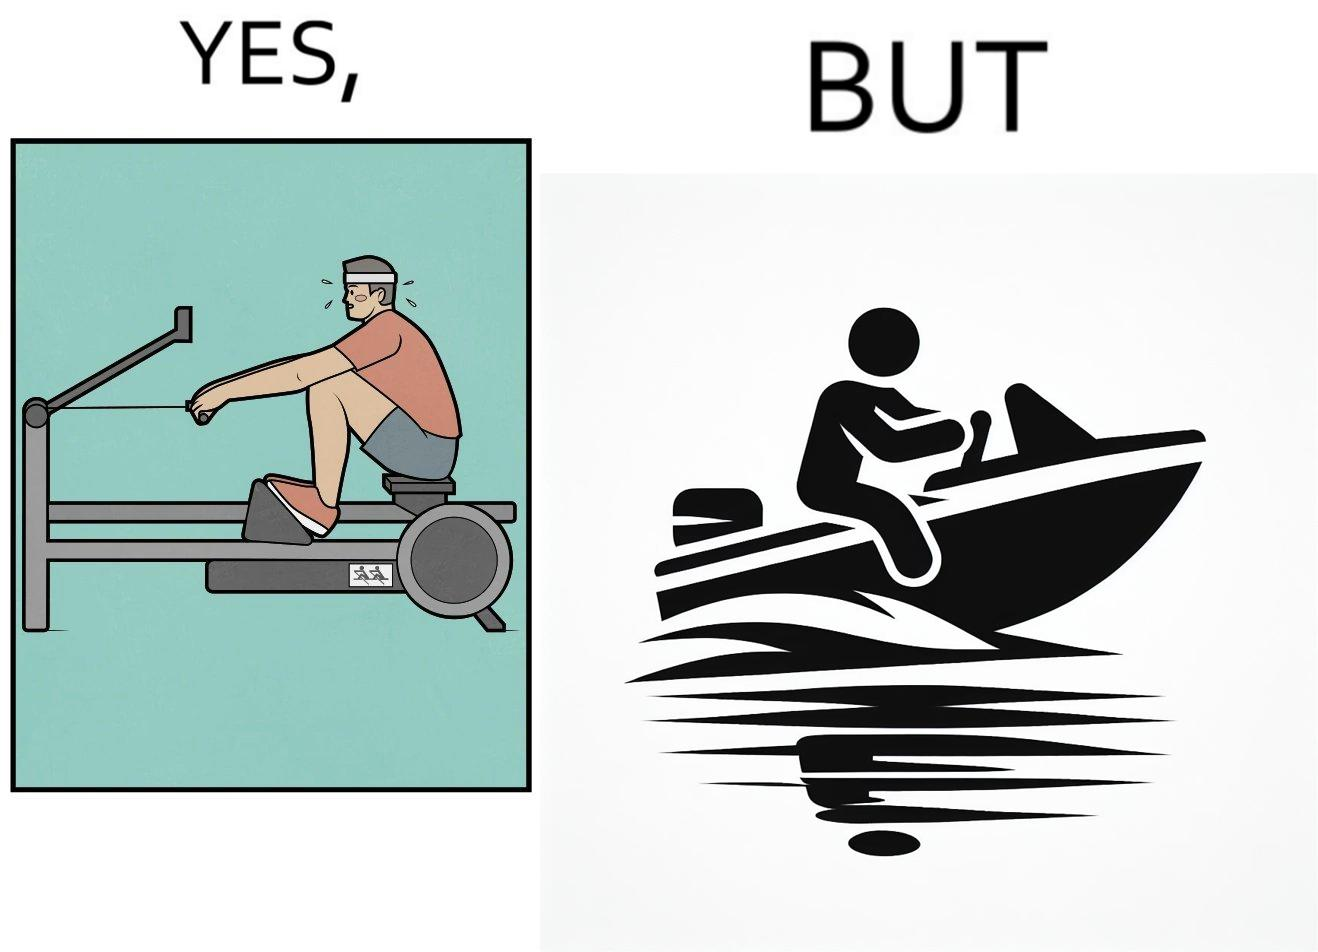What does this image depict? The image is ironic, because people often use rowing machine at the gym don't prefer rowing when it comes to boats 